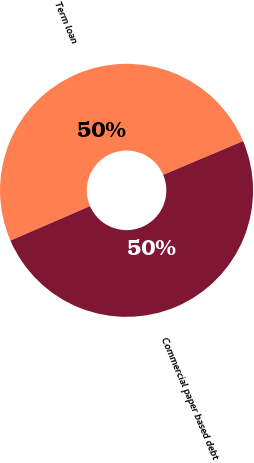Convert chart to OTSL. <chart><loc_0><loc_0><loc_500><loc_500><pie_chart><fcel>Term loan<fcel>Commercial paper based debt<nl><fcel>50.14%<fcel>49.86%<nl></chart> 